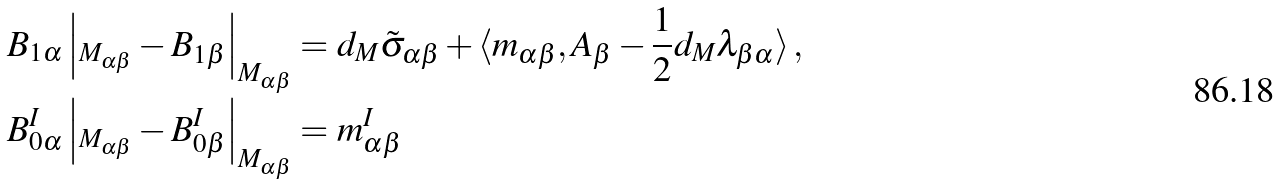Convert formula to latex. <formula><loc_0><loc_0><loc_500><loc_500>B _ { 1 \alpha } \left | _ { M _ { \alpha \beta } } - B _ { 1 \beta } \right | _ { M _ { \alpha \beta } } & = d _ { M } \tilde { \sigma } _ { \alpha \beta } + \langle m _ { \alpha \beta } , A _ { \beta } - \frac { 1 } { 2 } d _ { M } \lambda _ { \beta \alpha } \rangle \, , \\ B _ { 0 \alpha } ^ { I } \left | _ { M _ { \alpha \beta } } - B _ { 0 \beta } ^ { I } \right | _ { M _ { \alpha \beta } } & = m _ { \alpha \beta } ^ { I }</formula> 